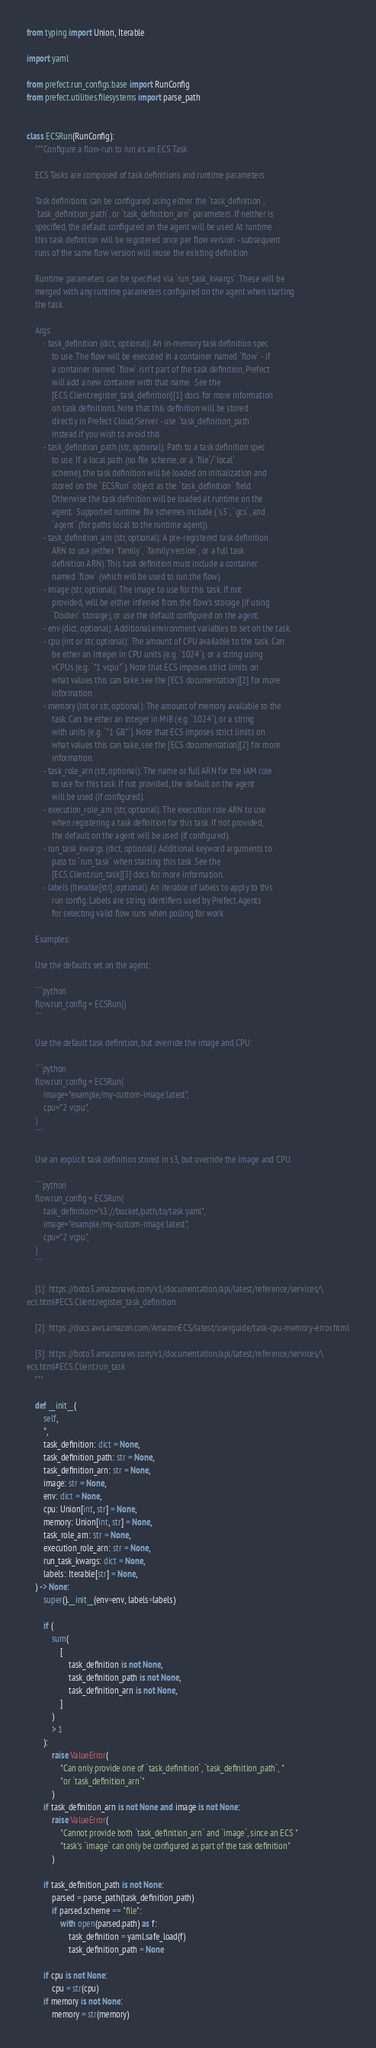Convert code to text. <code><loc_0><loc_0><loc_500><loc_500><_Python_>from typing import Union, Iterable

import yaml

from prefect.run_configs.base import RunConfig
from prefect.utilities.filesystems import parse_path


class ECSRun(RunConfig):
    """Configure a flow-run to run as an ECS Task.

    ECS Tasks are composed of task definitions and runtime parameters.

    Task definitions can be configured using either the `task_definition`,
    `task_definition_path`, or `task_definition_arn` parameters. If neither is
    specified, the default configured on the agent will be used. At runtime
    this task definition will be registered once per flow version - subsequent
    runs of the same flow version will reuse the existing definition.

    Runtime parameters can be specified via `run_task_kwargs`. These will be
    merged with any runtime parameters configured on the agent when starting
    the task.

    Args:
        - task_definition (dict, optional): An in-memory task definition spec
            to use. The flow will be executed in a container named `flow` - if
            a container named `flow` isn't part of the task definition, Prefect
            will add a new container with that name.  See the
            [ECS.Client.register_task_definition][1] docs for more information
            on task definitions. Note that this definition will be stored
            directly in Prefect Cloud/Server - use `task_definition_path`
            instead if you wish to avoid this.
        - task_definition_path (str, optional): Path to a task definition spec
            to use. If a local path (no file scheme, or a `file`/`local`
            scheme), the task definition will be loaded on initialization and
            stored on the `ECSRun` object as the `task_definition` field.
            Otherwise the task definition will be loaded at runtime on the
            agent.  Supported runtime file schemes include (`s3`, `gcs`, and
            `agent` (for paths local to the runtime agent)).
        - task_definition_arn (str, optional): A pre-registered task definition
            ARN to use (either `family`, `family:version`, or a full task
            definition ARN). This task definition must include a container
            named `flow` (which will be used to run the flow).
        - image (str, optional): The image to use for this task. If not
            provided, will be either inferred from the flow's storage (if using
            `Docker` storage), or use the default configured on the agent.
        - env (dict, optional): Additional environment variables to set on the task.
        - cpu (int or str, optional): The amount of CPU available to the task. Can
            be ether an integer in CPU units (e.g. `1024`), or a string using
            vCPUs (e.g. `"1 vcpu"`). Note that ECS imposes strict limits on
            what values this can take, see the [ECS documentation][2] for more
            information.
        - memory (int or str, optional): The amount of memory available to the
            task. Can be ether an integer in MiB (e.g. `1024`), or a string
            with units (e.g. `"1 GB"`). Note that ECS imposes strict limits on
            what values this can take, see the [ECS documentation][2] for more
            information.
        - task_role_arn (str, optional): The name or full ARN for the IAM role
            to use for this task. If not provided, the default on the agent
            will be used (if configured).
        - execution_role_arn (str, optional): The execution role ARN to use
            when registering a task definition for this task. If not provided,
            the default on the agent will be used (if configured).
        - run_task_kwargs (dict, optional): Additional keyword arguments to
            pass to `run_task` when starting this task. See the
            [ECS.Client.run_task][3] docs for more information.
        - labels (Iterable[str], optional): An iterable of labels to apply to this
            run config. Labels are string identifiers used by Prefect Agents
            for selecting valid flow runs when polling for work

    Examples:

    Use the defaults set on the agent:

    ```python
    flow.run_config = ECSRun()
    ```

    Use the default task definition, but override the image and CPU:

    ```python
    flow.run_config = ECSRun(
        image="example/my-custom-image:latest",
        cpu="2 vcpu",
    )
    ```

    Use an explicit task definition stored in s3, but override the image and CPU:

    ```python
    flow.run_config = ECSRun(
        task_definition="s3://bucket/path/to/task.yaml",
        image="example/my-custom-image:latest",
        cpu="2 vcpu",
    )
    ```

    [1]: https://boto3.amazonaws.com/v1/documentation/api/latest/reference/services/\
ecs.html#ECS.Client.register_task_definition

    [2]: https://docs.aws.amazon.com/AmazonECS/latest/userguide/task-cpu-memory-error.html

    [3]: https://boto3.amazonaws.com/v1/documentation/api/latest/reference/services/\
ecs.html#ECS.Client.run_task
    """

    def __init__(
        self,
        *,
        task_definition: dict = None,
        task_definition_path: str = None,
        task_definition_arn: str = None,
        image: str = None,
        env: dict = None,
        cpu: Union[int, str] = None,
        memory: Union[int, str] = None,
        task_role_arn: str = None,
        execution_role_arn: str = None,
        run_task_kwargs: dict = None,
        labels: Iterable[str] = None,
    ) -> None:
        super().__init__(env=env, labels=labels)

        if (
            sum(
                [
                    task_definition is not None,
                    task_definition_path is not None,
                    task_definition_arn is not None,
                ]
            )
            > 1
        ):
            raise ValueError(
                "Can only provide one of `task_definition`, `task_definition_path`, "
                "or `task_definition_arn`"
            )
        if task_definition_arn is not None and image is not None:
            raise ValueError(
                "Cannot provide both `task_definition_arn` and `image`, since an ECS "
                "task's `image` can only be configured as part of the task definition"
            )

        if task_definition_path is not None:
            parsed = parse_path(task_definition_path)
            if parsed.scheme == "file":
                with open(parsed.path) as f:
                    task_definition = yaml.safe_load(f)
                    task_definition_path = None

        if cpu is not None:
            cpu = str(cpu)
        if memory is not None:
            memory = str(memory)
</code> 